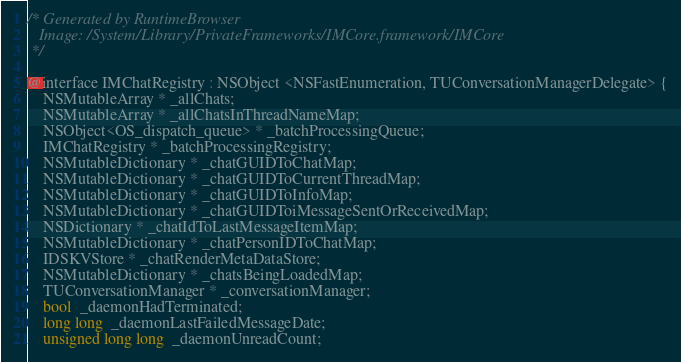<code> <loc_0><loc_0><loc_500><loc_500><_C_>/* Generated by RuntimeBrowser
   Image: /System/Library/PrivateFrameworks/IMCore.framework/IMCore
 */

@interface IMChatRegistry : NSObject <NSFastEnumeration, TUConversationManagerDelegate> {
    NSMutableArray * _allChats;
    NSMutableArray * _allChatsInThreadNameMap;
    NSObject<OS_dispatch_queue> * _batchProcessingQueue;
    IMChatRegistry * _batchProcessingRegistry;
    NSMutableDictionary * _chatGUIDToChatMap;
    NSMutableDictionary * _chatGUIDToCurrentThreadMap;
    NSMutableDictionary * _chatGUIDToInfoMap;
    NSMutableDictionary * _chatGUIDToiMessageSentOrReceivedMap;
    NSDictionary * _chatIdToLastMessageItemMap;
    NSMutableDictionary * _chatPersonIDToChatMap;
    IDSKVStore * _chatRenderMetaDataStore;
    NSMutableDictionary * _chatsBeingLoadedMap;
    TUConversationManager * _conversationManager;
    bool  _daemonHadTerminated;
    long long  _daemonLastFailedMessageDate;
    unsigned long long  _daemonUnreadCount;</code> 